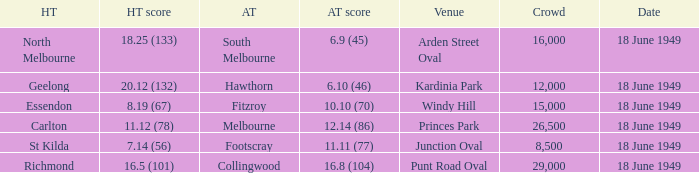What is the away team score when home team score is 20.12 (132)? 6.10 (46). 